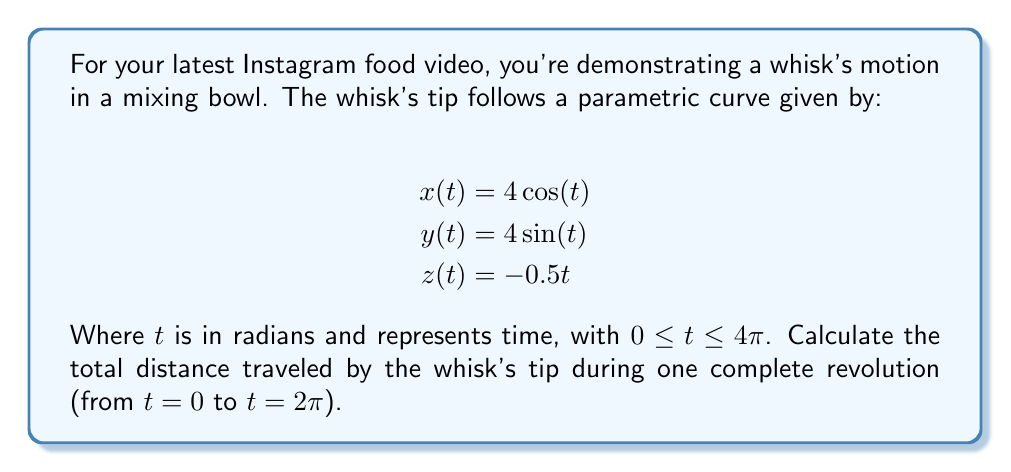Show me your answer to this math problem. To find the total distance traveled, we need to calculate the arc length of the parametric curve. The formula for arc length in 3D space is:

$$L = \int_a^b \sqrt{\left(\frac{dx}{dt}\right)^2 + \left(\frac{dy}{dt}\right)^2 + \left(\frac{dz}{dt}\right)^2} dt$$

Step 1: Find the derivatives
$\frac{dx}{dt} = -4\sin(t)$
$\frac{dy}{dt} = 4\cos(t)$
$\frac{dz}{dt} = -0.5$

Step 2: Square each derivative and add them
$$\left(\frac{dx}{dt}\right)^2 + \left(\frac{dy}{dt}\right)^2 + \left(\frac{dz}{dt}\right)^2 = 16\sin^2(t) + 16\cos^2(t) + 0.25$$

Step 3: Simplify using the identity $\sin^2(t) + \cos^2(t) = 1$
$$16\sin^2(t) + 16\cos^2(t) + 0.25 = 16 + 0.25 = 16.25$$

Step 4: Take the square root
$$\sqrt{16.25} = \sqrt{65}/2$$

Step 5: Integrate from 0 to $2\pi$
$$L = \int_0^{2\pi} \frac{\sqrt{65}}{2} dt = \frac{\sqrt{65}}{2} \cdot 2\pi = \pi\sqrt{65}$$

Therefore, the total distance traveled by the whisk's tip during one complete revolution is $\pi\sqrt{65}$ units.
Answer: $\pi\sqrt{65}$ units 